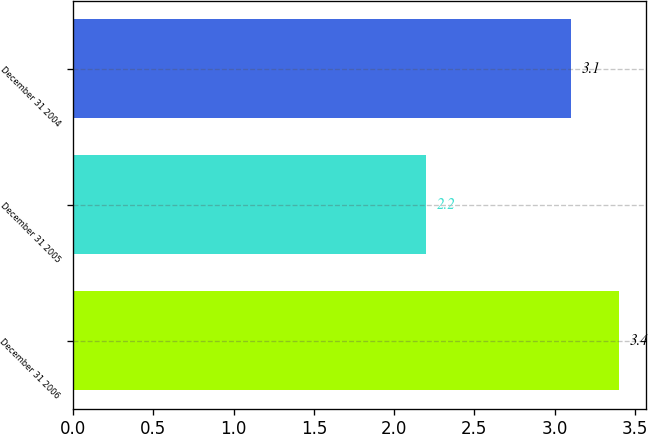Convert chart. <chart><loc_0><loc_0><loc_500><loc_500><bar_chart><fcel>December 31 2006<fcel>December 31 2005<fcel>December 31 2004<nl><fcel>3.4<fcel>2.2<fcel>3.1<nl></chart> 